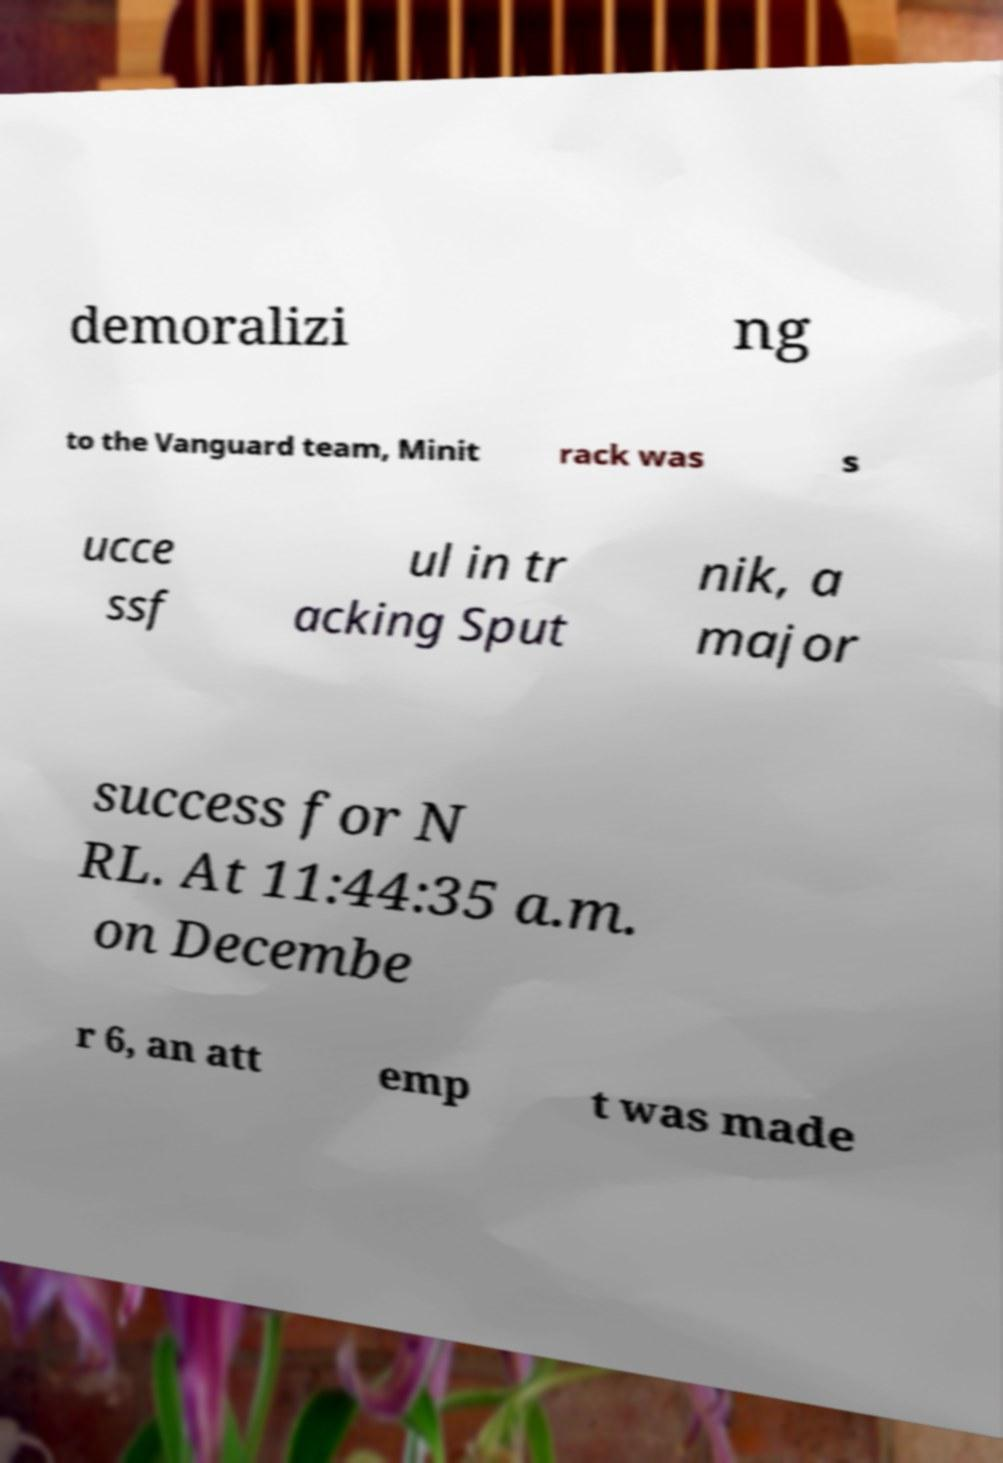Please identify and transcribe the text found in this image. demoralizi ng to the Vanguard team, Minit rack was s ucce ssf ul in tr acking Sput nik, a major success for N RL. At 11:44:35 a.m. on Decembe r 6, an att emp t was made 